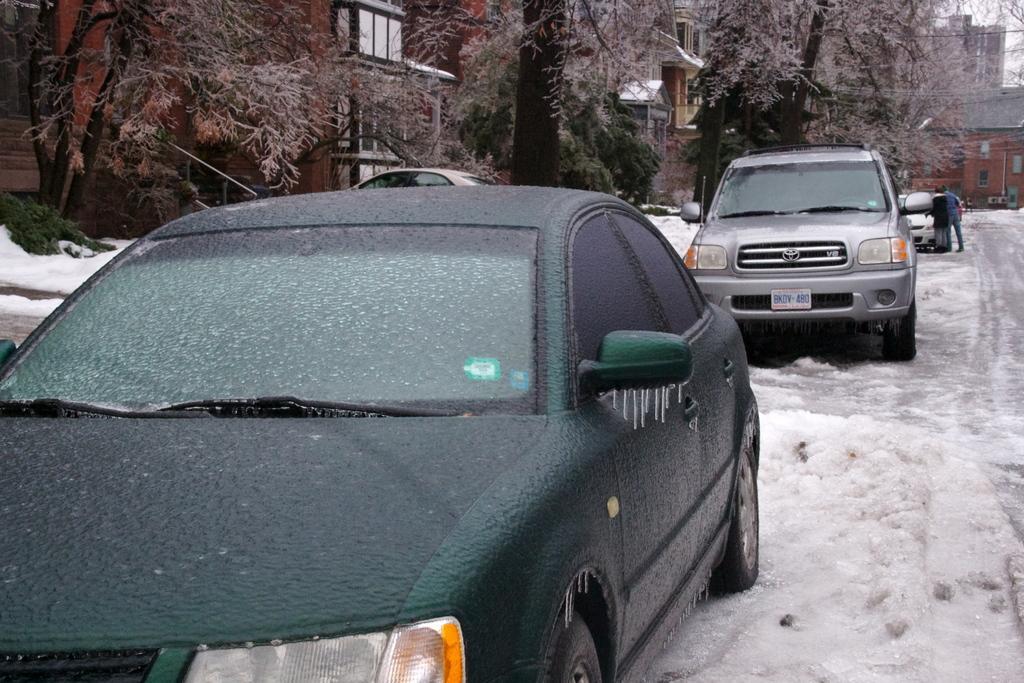Can you describe this image briefly? This image consists of cars. There is ice in this image. There are trees at the top. There are buildings at the top. There are some persons on the right side. 